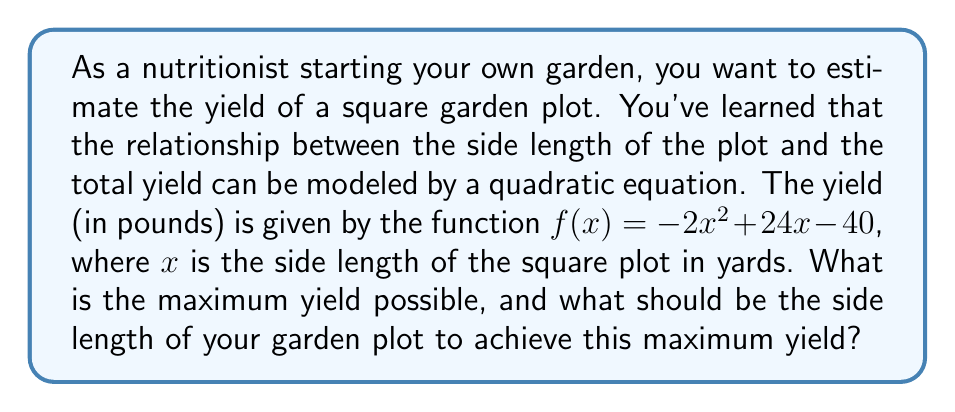Show me your answer to this math problem. To solve this problem, we need to find the maximum value of the quadratic function $f(x) = -2x^2 + 24x - 40$. We can do this by following these steps:

1. The quadratic function is in the form $f(x) = ax^2 + bx + c$, where:
   $a = -2$
   $b = 24$
   $c = -40$

2. For a quadratic function, the x-coordinate of the vertex represents the value of x that gives the maximum yield. We can find this using the formula: $x = -\frac{b}{2a}$

3. Substituting the values:
   $x = -\frac{24}{2(-2)} = -\frac{24}{-4} = 6$

4. So, the side length that gives the maximum yield is 6 yards.

5. To find the maximum yield, we substitute x = 6 into the original function:
   $f(6) = -2(6)^2 + 24(6) - 40$
   $= -2(36) + 144 - 40$
   $= -72 + 144 - 40$
   $= 32$

Therefore, the maximum yield is 32 pounds, and this occurs when the side length of the square garden plot is 6 yards.
Answer: The maximum yield is 32 pounds, achieved with a square garden plot with side length 6 yards. 